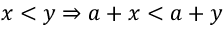Convert formula to latex. <formula><loc_0><loc_0><loc_500><loc_500>x < y \Rightarrow a + x < a + y</formula> 